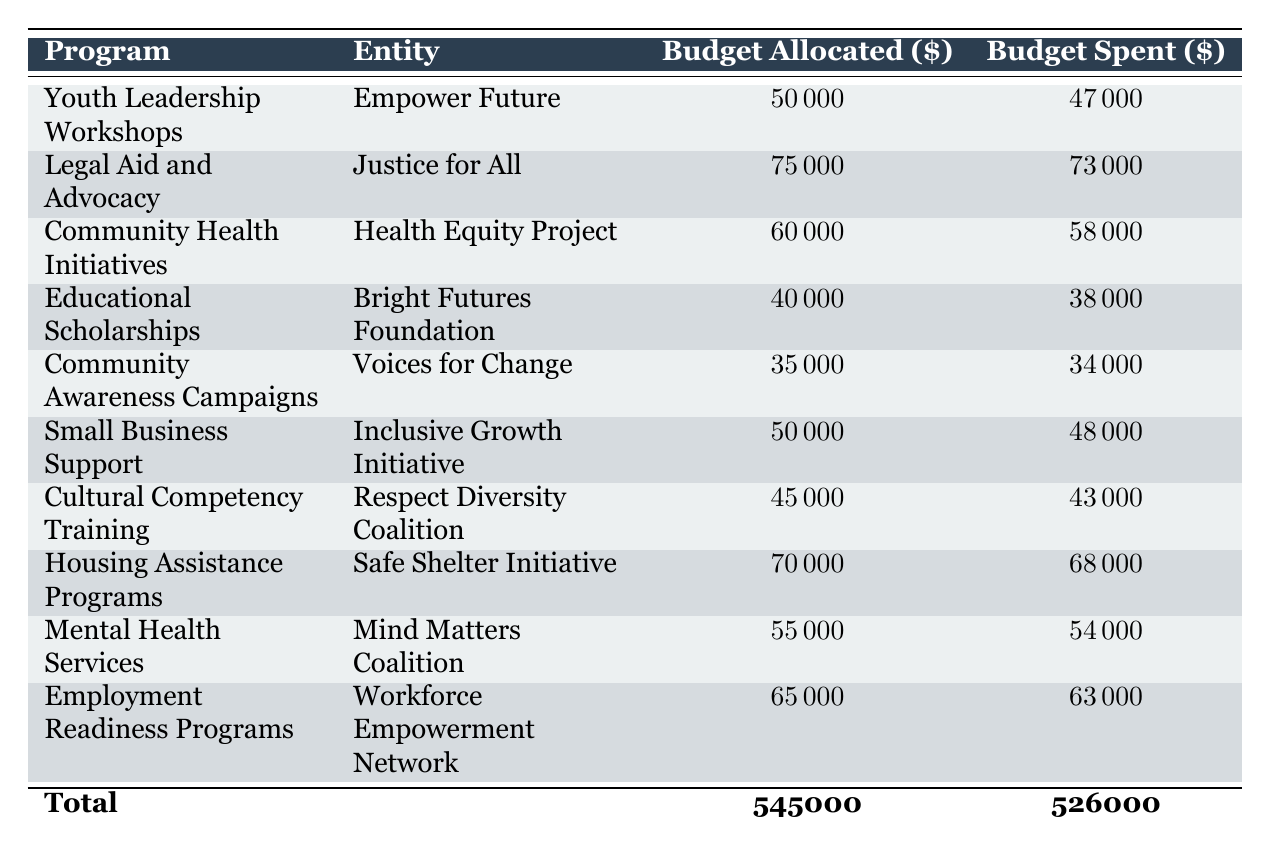What is the budget allocated for the Community Awareness Campaigns program? The table clearly shows that the budget allocated for the Community Awareness Campaigns program, which is listed under the relevant program name, is $35,000.
Answer: 35000 Which entity manages the Legal Aid and Advocacy program? The table lists the Legal Aid and Advocacy program and specifies that it is managed by the entity called Justice for All.
Answer: Justice for All How much total budget was spent across all programs? The total budget spent is given at the bottom of the table, which sums up to $526,000, calculated by adding the spent amounts from each program.
Answer: 526000 What is the difference between the total budget allocated and the total budget spent? To find the difference, subtract the total budget spent ($526,000) from the total budget allocated ($545,000): 545000 - 526000 = 19000.
Answer: 19000 Did the Youth Leadership Workshops program spend more than 90% of its allocated budget? The budget spent for the Youth Leadership Workshops is $47,000 out of the $50,000 allocated. To check the percentage: (47000/50000)*100 = 94%, which is indeed more than 90%.
Answer: Yes How many more people were served by the Community Health Initiatives program than the Educational Scholarships program? The Community Health Initiatives program served 3,000 people, while the Educational Scholarships program awarded scholarships to 25 students. Thus, the difference is: 3000 - 25 = 2975.
Answer: 2975 What percentage of the budget allocated was spent on the Cultural Competency Training program? The Cultural Competency Training program had a budget allocated of $45,000 and spent $43,000. The percentage spent is calculated as (43000/45000)*100 ≈ 95.56%.
Answer: 95.56% Which program has the highest budget allocation and what is that amount? The program with the highest budget allocation is the Legal Aid and Advocacy program, with an allocated budget of $75,000.
Answer: 75000 Are there more training sessions conducted in the Cultural Competency Training program than participants trained in the Employment Readiness Programs? The Cultural Competency Training program conducted 8 trainings while the Employment Readiness Programs had 300 participants enrolled. So, 8 is less than 300, meaning the statement is false.
Answer: No 